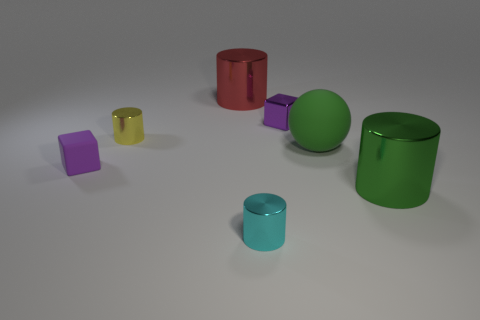Subtract all cyan cylinders. How many cylinders are left? 3 Subtract all big green cylinders. How many cylinders are left? 3 Subtract all cylinders. How many objects are left? 3 Subtract 1 cubes. How many cubes are left? 1 Subtract all brown balls. How many yellow cylinders are left? 1 Subtract all large blue cylinders. Subtract all matte spheres. How many objects are left? 6 Add 4 red metallic objects. How many red metallic objects are left? 5 Add 5 red metal cylinders. How many red metal cylinders exist? 6 Add 2 small matte blocks. How many objects exist? 9 Subtract 0 red spheres. How many objects are left? 7 